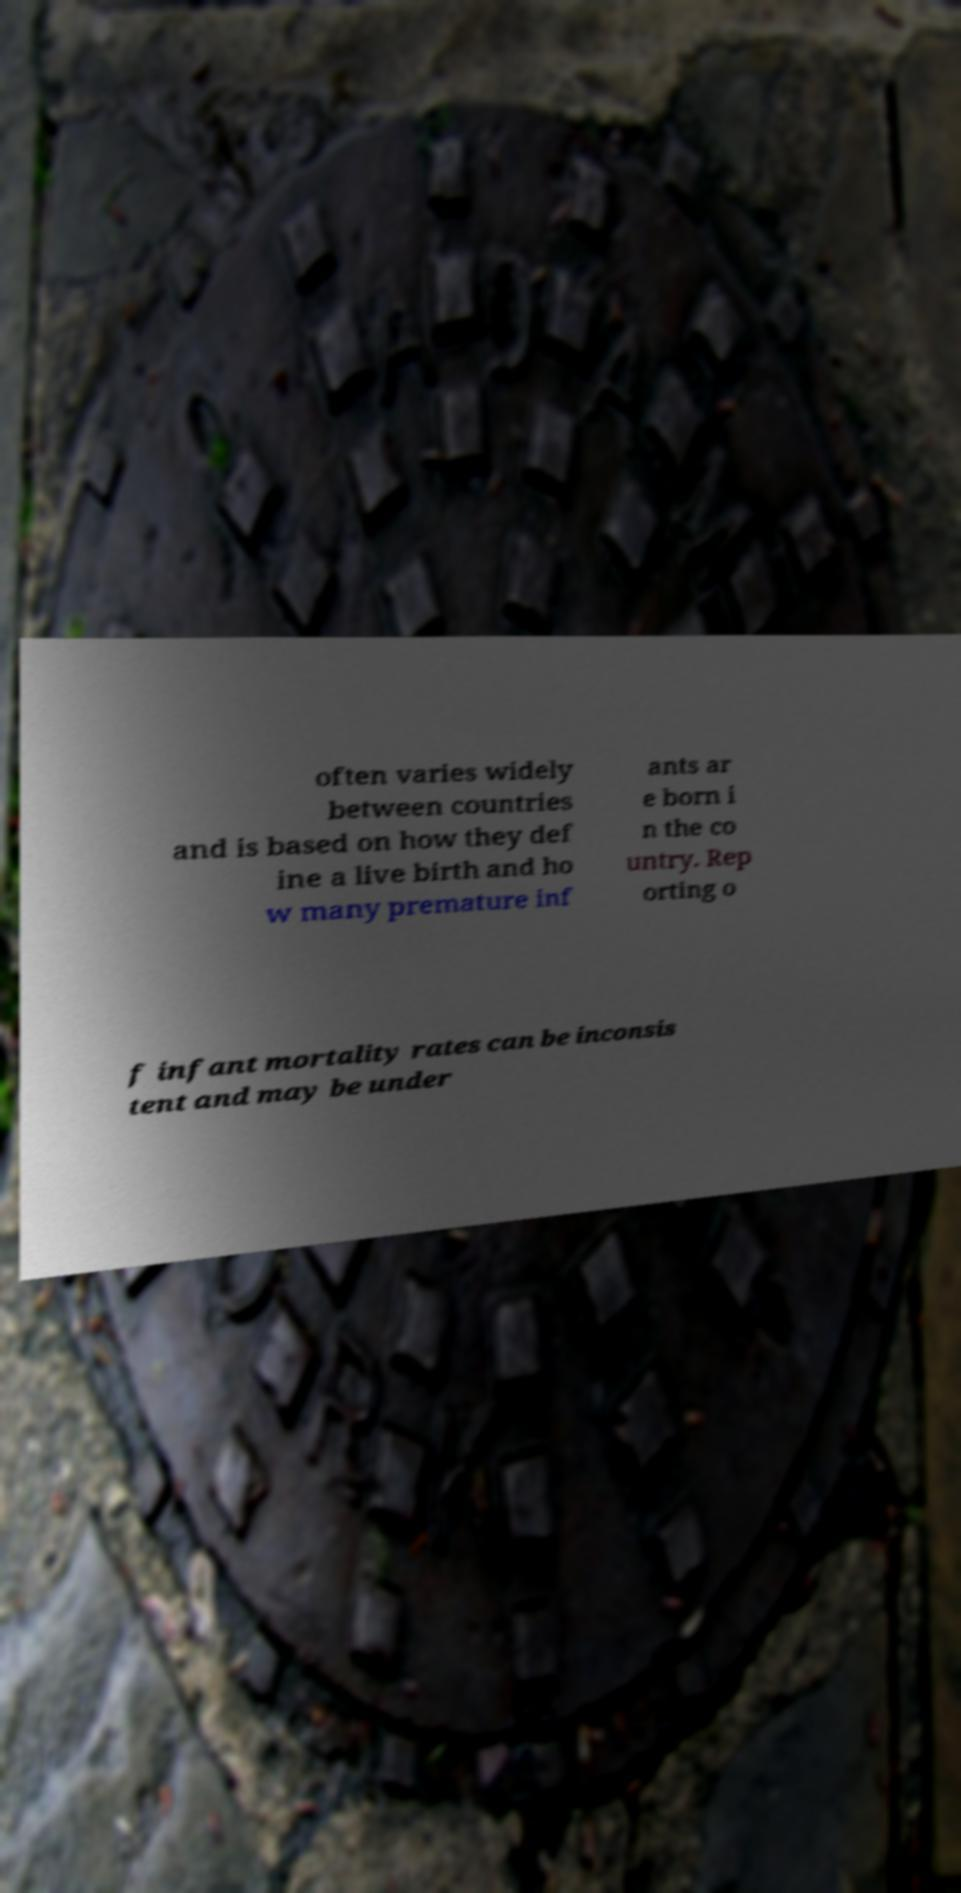Could you extract and type out the text from this image? often varies widely between countries and is based on how they def ine a live birth and ho w many premature inf ants ar e born i n the co untry. Rep orting o f infant mortality rates can be inconsis tent and may be under 